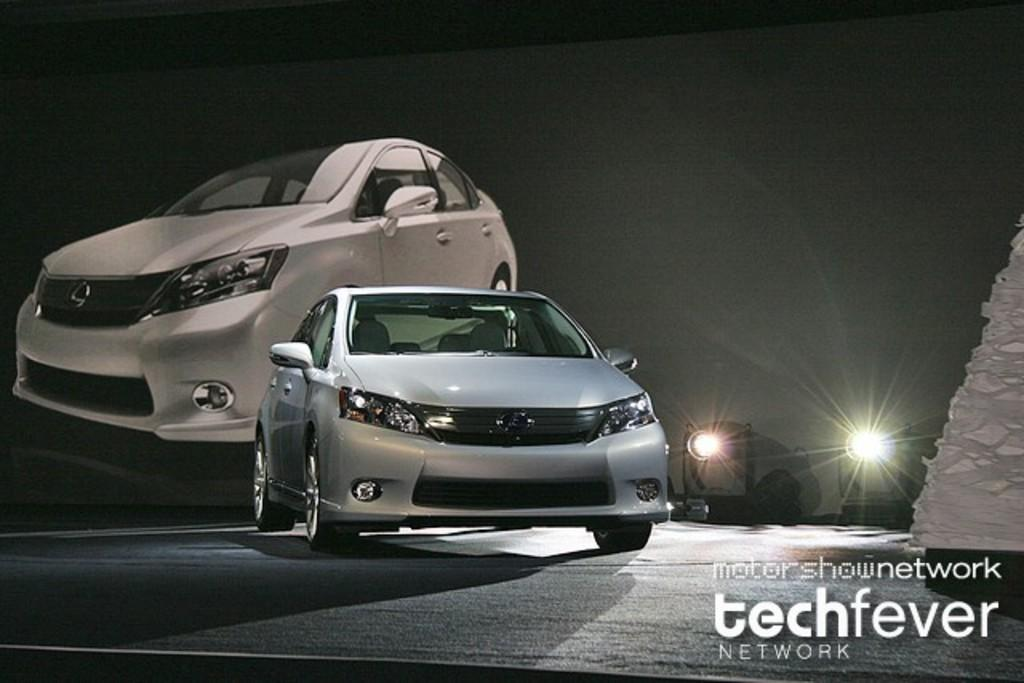What is the main subject of the image? There is a car in the image. Can you describe the car's position in the image? The car is on a surface in the image. What can be seen in the background of the image? There are lights and a banner in the background of the image. What is present on the right side of the image? There is a white object on the right side of the image, and it has text associated with it. What type of breakfast is being served in the car in the image? There is no breakfast present in the image; it only features a car on a surface with a white object and text on the right side. 